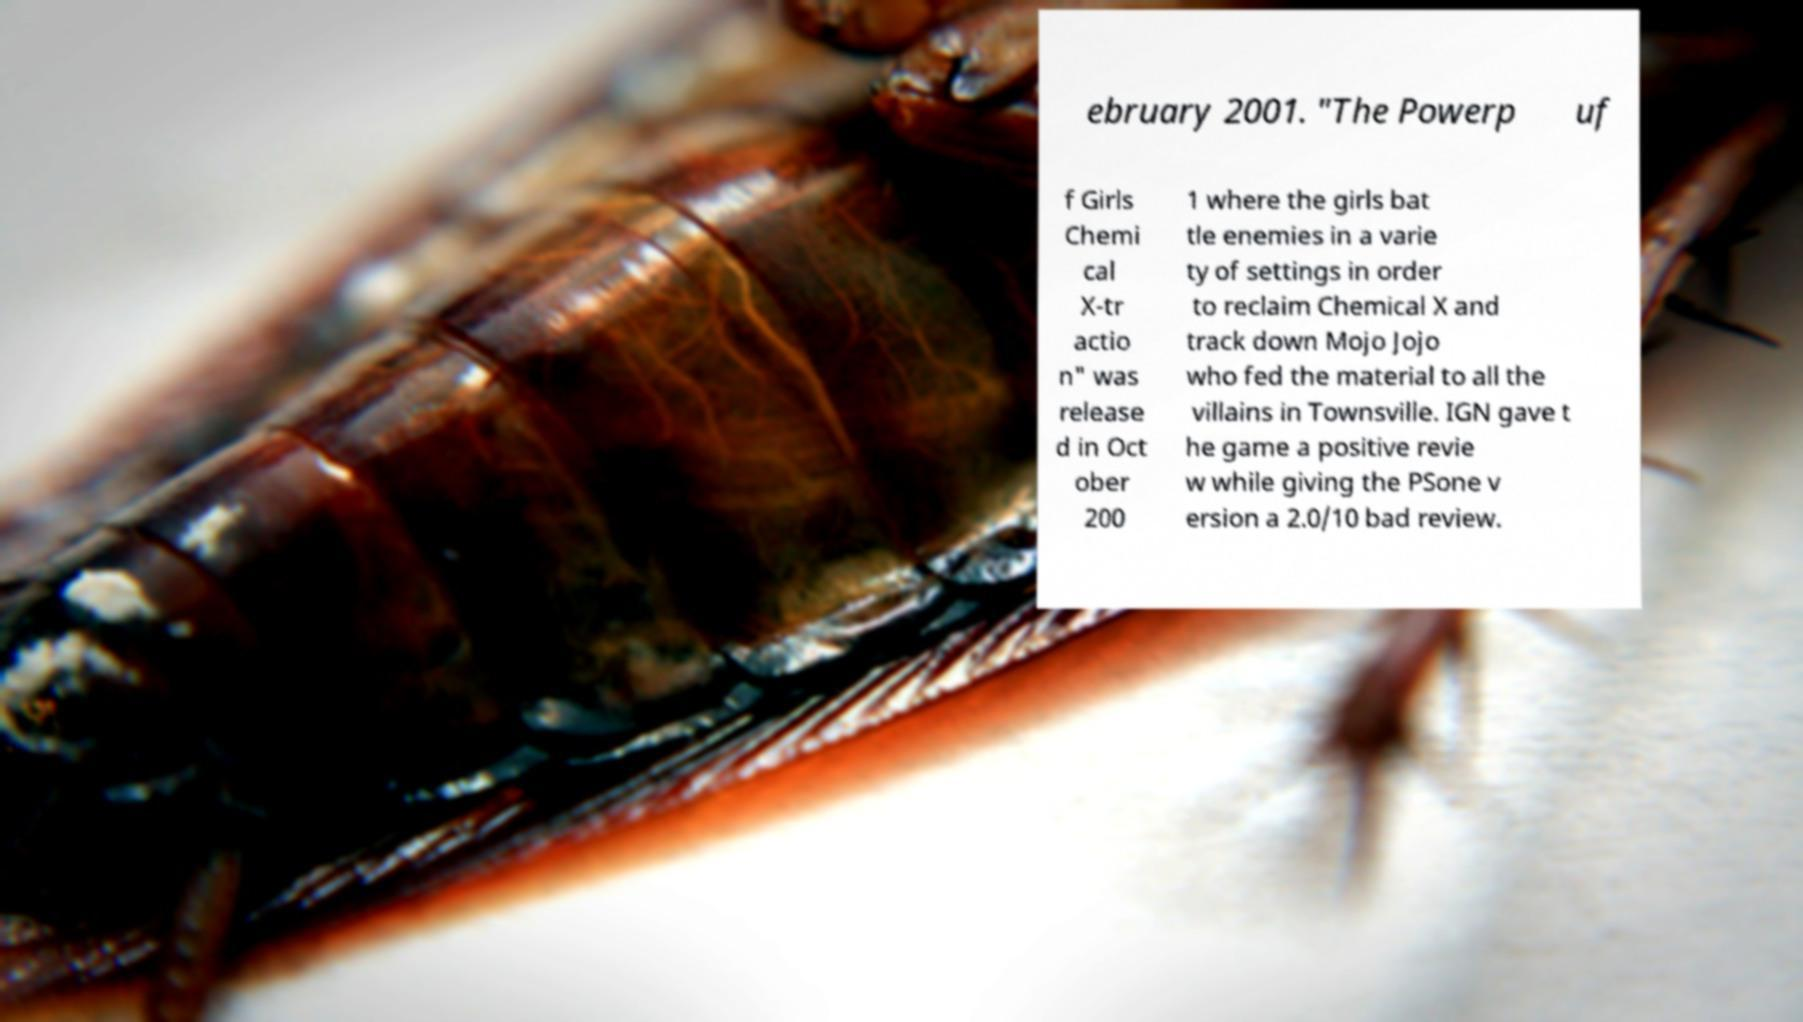Please read and relay the text visible in this image. What does it say? ebruary 2001. "The Powerp uf f Girls Chemi cal X-tr actio n" was release d in Oct ober 200 1 where the girls bat tle enemies in a varie ty of settings in order to reclaim Chemical X and track down Mojo Jojo who fed the material to all the villains in Townsville. IGN gave t he game a positive revie w while giving the PSone v ersion a 2.0/10 bad review. 